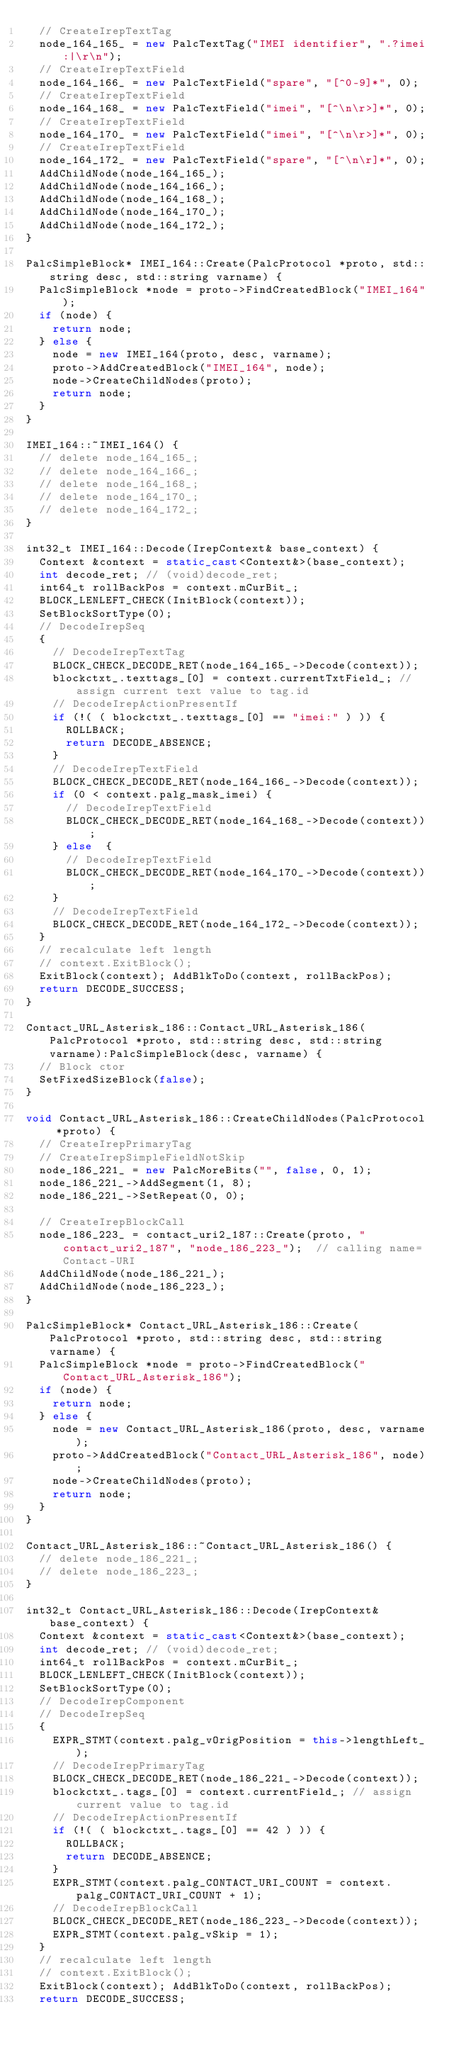Convert code to text. <code><loc_0><loc_0><loc_500><loc_500><_C++_>  // CreateIrepTextTag
  node_164_165_ = new PalcTextTag("IMEI identifier", ".?imei:|\r\n");
  // CreateIrepTextField
  node_164_166_ = new PalcTextField("spare", "[^0-9]*", 0);
  // CreateIrepTextField
  node_164_168_ = new PalcTextField("imei", "[^\n\r>]*", 0);
  // CreateIrepTextField
  node_164_170_ = new PalcTextField("imei", "[^\n\r>]*", 0);
  // CreateIrepTextField
  node_164_172_ = new PalcTextField("spare", "[^\n\r]*", 0);
  AddChildNode(node_164_165_);
  AddChildNode(node_164_166_);
  AddChildNode(node_164_168_);
  AddChildNode(node_164_170_);
  AddChildNode(node_164_172_);
}

PalcSimpleBlock* IMEI_164::Create(PalcProtocol *proto, std::string desc, std::string varname) {
  PalcSimpleBlock *node = proto->FindCreatedBlock("IMEI_164");
  if (node) {
    return node;
  } else {
    node = new IMEI_164(proto, desc, varname);
    proto->AddCreatedBlock("IMEI_164", node);
    node->CreateChildNodes(proto);
    return node;
  }
}

IMEI_164::~IMEI_164() {
  // delete node_164_165_;
  // delete node_164_166_;
  // delete node_164_168_;
  // delete node_164_170_;
  // delete node_164_172_;
}

int32_t IMEI_164::Decode(IrepContext& base_context) {  
  Context &context = static_cast<Context&>(base_context);
  int decode_ret; // (void)decode_ret;
  int64_t rollBackPos = context.mCurBit_;
  BLOCK_LENLEFT_CHECK(InitBlock(context)); 
  SetBlockSortType(0);
  // DecodeIrepSeq
  {
    // DecodeIrepTextTag
    BLOCK_CHECK_DECODE_RET(node_164_165_->Decode(context));
    blockctxt_.texttags_[0] = context.currentTxtField_; // assign current text value to tag.id
    // DecodeIrepActionPresentIf
    if (!( ( blockctxt_.texttags_[0] == "imei:" ) )) {    
      ROLLBACK;
      return DECODE_ABSENCE;
    } 
    // DecodeIrepTextField
    BLOCK_CHECK_DECODE_RET(node_164_166_->Decode(context));
    if (0 < context.palg_mask_imei) {
      // DecodeIrepTextField
      BLOCK_CHECK_DECODE_RET(node_164_168_->Decode(context));
    } else  {
      // DecodeIrepTextField
      BLOCK_CHECK_DECODE_RET(node_164_170_->Decode(context));
    }
    // DecodeIrepTextField
    BLOCK_CHECK_DECODE_RET(node_164_172_->Decode(context));
  }
  // recalculate left length
  // context.ExitBlock();
  ExitBlock(context); AddBlkToDo(context, rollBackPos);
  return DECODE_SUCCESS;
}

Contact_URL_Asterisk_186::Contact_URL_Asterisk_186(PalcProtocol *proto, std::string desc, std::string varname):PalcSimpleBlock(desc, varname) {
  // Block ctor
  SetFixedSizeBlock(false);
}

void Contact_URL_Asterisk_186::CreateChildNodes(PalcProtocol *proto) {
  // CreateIrepPrimaryTag
  // CreateIrepSimpleFieldNotSkip
  node_186_221_ = new PalcMoreBits("", false, 0, 1);
  node_186_221_->AddSegment(1, 8);
  node_186_221_->SetRepeat(0, 0);

  // CreateIrepBlockCall
  node_186_223_ = contact_uri2_187::Create(proto, "contact_uri2_187", "node_186_223_");  // calling name=Contact-URI
  AddChildNode(node_186_221_);
  AddChildNode(node_186_223_);
}

PalcSimpleBlock* Contact_URL_Asterisk_186::Create(PalcProtocol *proto, std::string desc, std::string varname) {
  PalcSimpleBlock *node = proto->FindCreatedBlock("Contact_URL_Asterisk_186");
  if (node) {
    return node;
  } else {
    node = new Contact_URL_Asterisk_186(proto, desc, varname);
    proto->AddCreatedBlock("Contact_URL_Asterisk_186", node);
    node->CreateChildNodes(proto);
    return node;
  }
}

Contact_URL_Asterisk_186::~Contact_URL_Asterisk_186() {
  // delete node_186_221_;
  // delete node_186_223_;
}

int32_t Contact_URL_Asterisk_186::Decode(IrepContext& base_context) {  
  Context &context = static_cast<Context&>(base_context);
  int decode_ret; // (void)decode_ret;
  int64_t rollBackPos = context.mCurBit_;
  BLOCK_LENLEFT_CHECK(InitBlock(context)); 
  SetBlockSortType(0);
  // DecodeIrepComponent
  // DecodeIrepSeq
  {
    EXPR_STMT(context.palg_vOrigPosition = this->lengthLeft_);
    // DecodeIrepPrimaryTag
    BLOCK_CHECK_DECODE_RET(node_186_221_->Decode(context));
    blockctxt_.tags_[0] = context.currentField_; // assign current value to tag.id
    // DecodeIrepActionPresentIf
    if (!( ( blockctxt_.tags_[0] == 42 ) )) {    
      ROLLBACK;
      return DECODE_ABSENCE;
    } 
    EXPR_STMT(context.palg_CONTACT_URI_COUNT = context.palg_CONTACT_URI_COUNT + 1);
    // DecodeIrepBlockCall
    BLOCK_CHECK_DECODE_RET(node_186_223_->Decode(context));
    EXPR_STMT(context.palg_vSkip = 1);
  }
  // recalculate left length
  // context.ExitBlock();
  ExitBlock(context); AddBlkToDo(context, rollBackPos);
  return DECODE_SUCCESS;</code> 